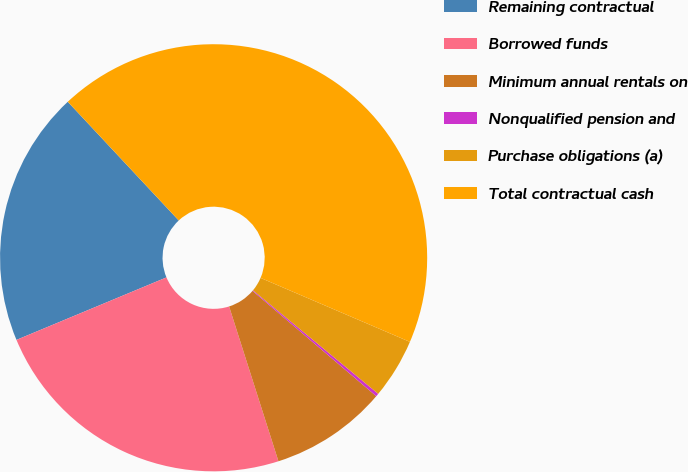Convert chart. <chart><loc_0><loc_0><loc_500><loc_500><pie_chart><fcel>Remaining contractual<fcel>Borrowed funds<fcel>Minimum annual rentals on<fcel>Nonqualified pension and<fcel>Purchase obligations (a)<fcel>Total contractual cash<nl><fcel>19.32%<fcel>23.63%<fcel>8.87%<fcel>0.23%<fcel>4.55%<fcel>43.41%<nl></chart> 